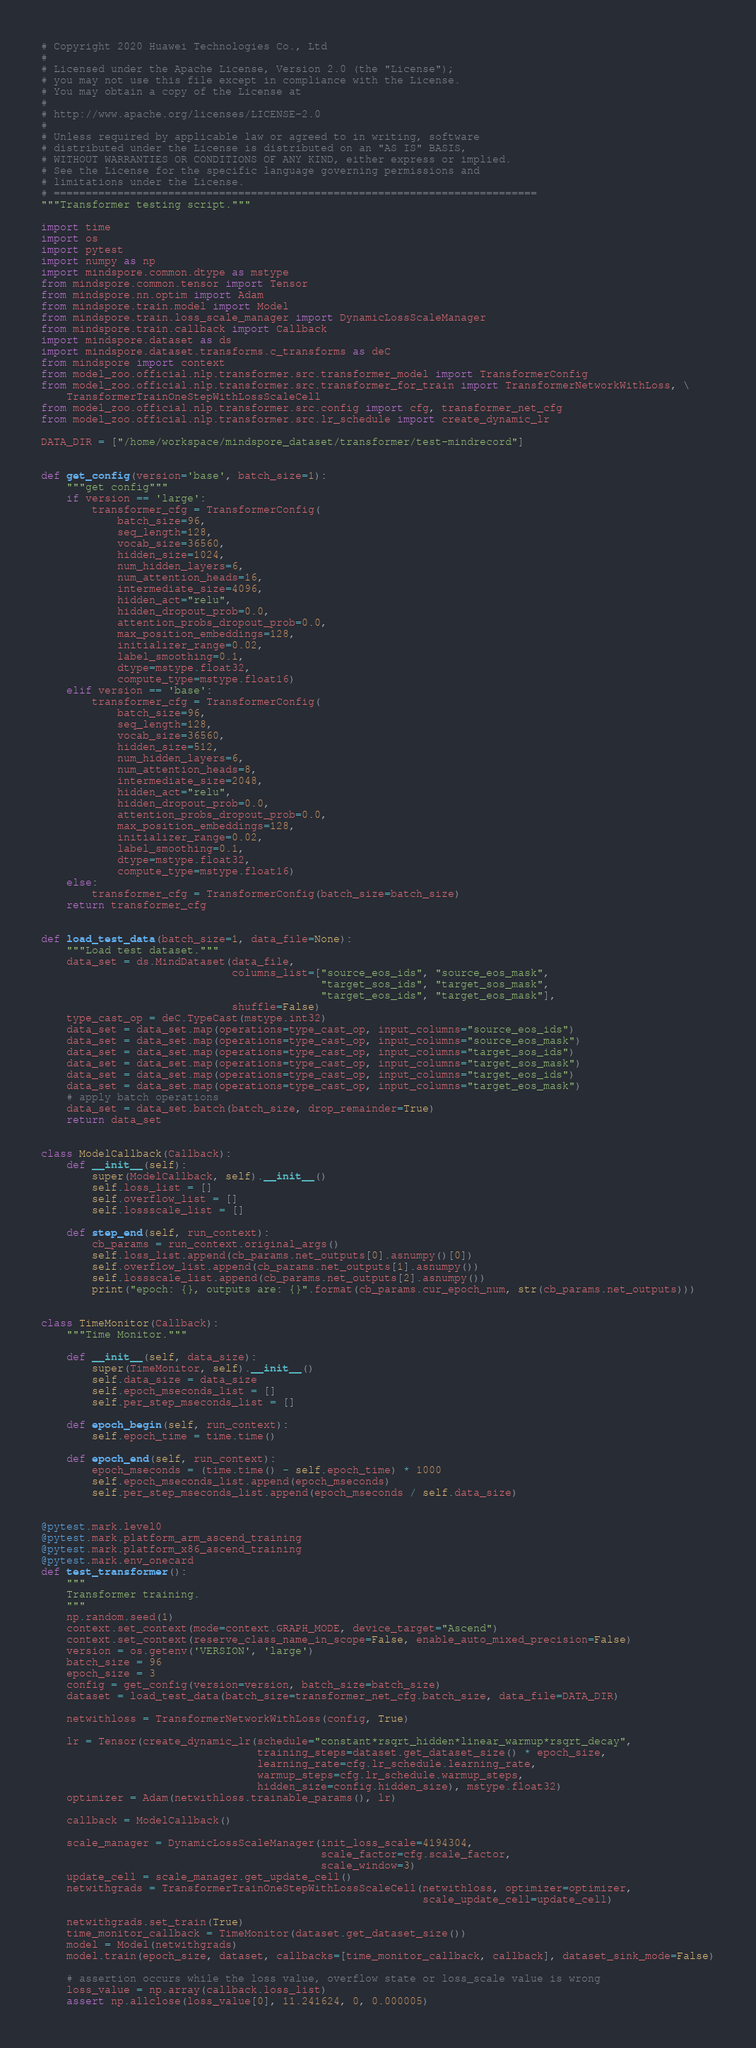<code> <loc_0><loc_0><loc_500><loc_500><_Python_># Copyright 2020 Huawei Technologies Co., Ltd
#
# Licensed under the Apache License, Version 2.0 (the "License");
# you may not use this file except in compliance with the License.
# You may obtain a copy of the License at
#
# http://www.apache.org/licenses/LICENSE-2.0
#
# Unless required by applicable law or agreed to in writing, software
# distributed under the License is distributed on an "AS IS" BASIS,
# WITHOUT WARRANTIES OR CONDITIONS OF ANY KIND, either express or implied.
# See the License for the specific language governing permissions and
# limitations under the License.
# ============================================================================
"""Transformer testing script."""

import time
import os
import pytest
import numpy as np
import mindspore.common.dtype as mstype
from mindspore.common.tensor import Tensor
from mindspore.nn.optim import Adam
from mindspore.train.model import Model
from mindspore.train.loss_scale_manager import DynamicLossScaleManager
from mindspore.train.callback import Callback
import mindspore.dataset as ds
import mindspore.dataset.transforms.c_transforms as deC
from mindspore import context
from model_zoo.official.nlp.transformer.src.transformer_model import TransformerConfig
from model_zoo.official.nlp.transformer.src.transformer_for_train import TransformerNetworkWithLoss, \
    TransformerTrainOneStepWithLossScaleCell
from model_zoo.official.nlp.transformer.src.config import cfg, transformer_net_cfg
from model_zoo.official.nlp.transformer.src.lr_schedule import create_dynamic_lr

DATA_DIR = ["/home/workspace/mindspore_dataset/transformer/test-mindrecord"]


def get_config(version='base', batch_size=1):
    """get config"""
    if version == 'large':
        transformer_cfg = TransformerConfig(
            batch_size=96,
            seq_length=128,
            vocab_size=36560,
            hidden_size=1024,
            num_hidden_layers=6,
            num_attention_heads=16,
            intermediate_size=4096,
            hidden_act="relu",
            hidden_dropout_prob=0.0,
            attention_probs_dropout_prob=0.0,
            max_position_embeddings=128,
            initializer_range=0.02,
            label_smoothing=0.1,
            dtype=mstype.float32,
            compute_type=mstype.float16)
    elif version == 'base':
        transformer_cfg = TransformerConfig(
            batch_size=96,
            seq_length=128,
            vocab_size=36560,
            hidden_size=512,
            num_hidden_layers=6,
            num_attention_heads=8,
            intermediate_size=2048,
            hidden_act="relu",
            hidden_dropout_prob=0.0,
            attention_probs_dropout_prob=0.0,
            max_position_embeddings=128,
            initializer_range=0.02,
            label_smoothing=0.1,
            dtype=mstype.float32,
            compute_type=mstype.float16)
    else:
        transformer_cfg = TransformerConfig(batch_size=batch_size)
    return transformer_cfg


def load_test_data(batch_size=1, data_file=None):
    """Load test dataset."""
    data_set = ds.MindDataset(data_file,
                              columns_list=["source_eos_ids", "source_eos_mask",
                                            "target_sos_ids", "target_sos_mask",
                                            "target_eos_ids", "target_eos_mask"],
                              shuffle=False)
    type_cast_op = deC.TypeCast(mstype.int32)
    data_set = data_set.map(operations=type_cast_op, input_columns="source_eos_ids")
    data_set = data_set.map(operations=type_cast_op, input_columns="source_eos_mask")
    data_set = data_set.map(operations=type_cast_op, input_columns="target_sos_ids")
    data_set = data_set.map(operations=type_cast_op, input_columns="target_sos_mask")
    data_set = data_set.map(operations=type_cast_op, input_columns="target_eos_ids")
    data_set = data_set.map(operations=type_cast_op, input_columns="target_eos_mask")
    # apply batch operations
    data_set = data_set.batch(batch_size, drop_remainder=True)
    return data_set


class ModelCallback(Callback):
    def __init__(self):
        super(ModelCallback, self).__init__()
        self.loss_list = []
        self.overflow_list = []
        self.lossscale_list = []

    def step_end(self, run_context):
        cb_params = run_context.original_args()
        self.loss_list.append(cb_params.net_outputs[0].asnumpy()[0])
        self.overflow_list.append(cb_params.net_outputs[1].asnumpy())
        self.lossscale_list.append(cb_params.net_outputs[2].asnumpy())
        print("epoch: {}, outputs are: {}".format(cb_params.cur_epoch_num, str(cb_params.net_outputs)))


class TimeMonitor(Callback):
    """Time Monitor."""

    def __init__(self, data_size):
        super(TimeMonitor, self).__init__()
        self.data_size = data_size
        self.epoch_mseconds_list = []
        self.per_step_mseconds_list = []

    def epoch_begin(self, run_context):
        self.epoch_time = time.time()

    def epoch_end(self, run_context):
        epoch_mseconds = (time.time() - self.epoch_time) * 1000
        self.epoch_mseconds_list.append(epoch_mseconds)
        self.per_step_mseconds_list.append(epoch_mseconds / self.data_size)


@pytest.mark.level0
@pytest.mark.platform_arm_ascend_training
@pytest.mark.platform_x86_ascend_training
@pytest.mark.env_onecard
def test_transformer():
    """
    Transformer training.
    """
    np.random.seed(1)
    context.set_context(mode=context.GRAPH_MODE, device_target="Ascend")
    context.set_context(reserve_class_name_in_scope=False, enable_auto_mixed_precision=False)
    version = os.getenv('VERSION', 'large')
    batch_size = 96
    epoch_size = 3
    config = get_config(version=version, batch_size=batch_size)
    dataset = load_test_data(batch_size=transformer_net_cfg.batch_size, data_file=DATA_DIR)

    netwithloss = TransformerNetworkWithLoss(config, True)

    lr = Tensor(create_dynamic_lr(schedule="constant*rsqrt_hidden*linear_warmup*rsqrt_decay",
                                  training_steps=dataset.get_dataset_size() * epoch_size,
                                  learning_rate=cfg.lr_schedule.learning_rate,
                                  warmup_steps=cfg.lr_schedule.warmup_steps,
                                  hidden_size=config.hidden_size), mstype.float32)
    optimizer = Adam(netwithloss.trainable_params(), lr)

    callback = ModelCallback()

    scale_manager = DynamicLossScaleManager(init_loss_scale=4194304,
                                            scale_factor=cfg.scale_factor,
                                            scale_window=3)
    update_cell = scale_manager.get_update_cell()
    netwithgrads = TransformerTrainOneStepWithLossScaleCell(netwithloss, optimizer=optimizer,
                                                            scale_update_cell=update_cell)

    netwithgrads.set_train(True)
    time_monitor_callback = TimeMonitor(dataset.get_dataset_size())
    model = Model(netwithgrads)
    model.train(epoch_size, dataset, callbacks=[time_monitor_callback, callback], dataset_sink_mode=False)

    # assertion occurs while the loss value, overflow state or loss_scale value is wrong
    loss_value = np.array(callback.loss_list)
    assert np.allclose(loss_value[0], 11.241624, 0, 0.000005)
</code> 